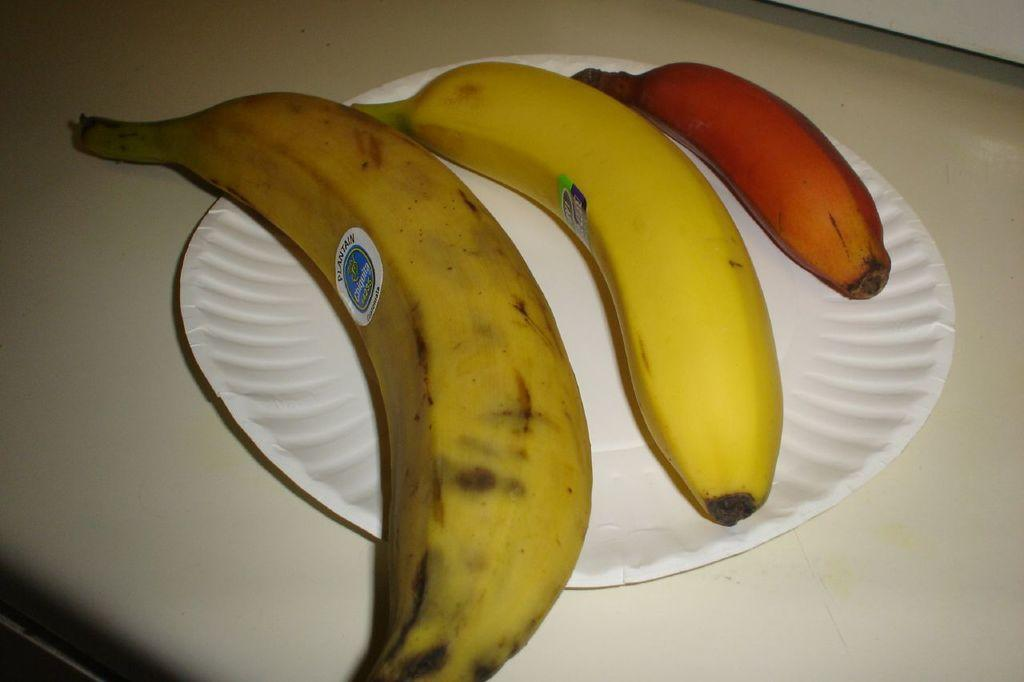How many bananas are visible in the image? There are three bananas in the image. What are the bananas placed on? The bananas are on a paper plate. Where is the paper plate located? The paper plate is on a platform. What type of organization is responsible for maintaining the garden in the image? There is no garden present in the image, so it is not possible to determine which organization might be responsible for maintaining it. 